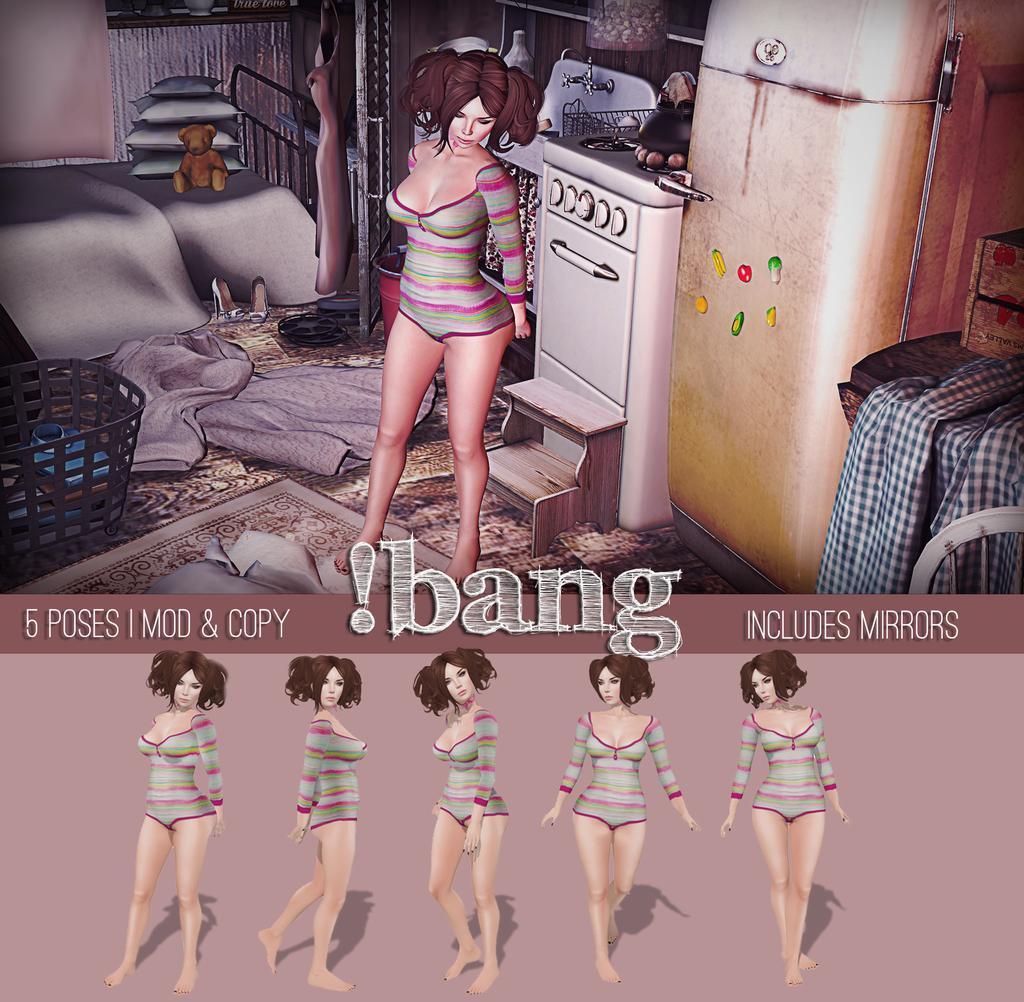How would you summarize this image in a sentence or two? In this image we can see an animation picture. In the picture there are pillows, soft toy, bed, carpet, laundry basket, dish washer, sink, tap, woman standing on the floor and walls. At the bottom of the image we can see the woman in different poses. 